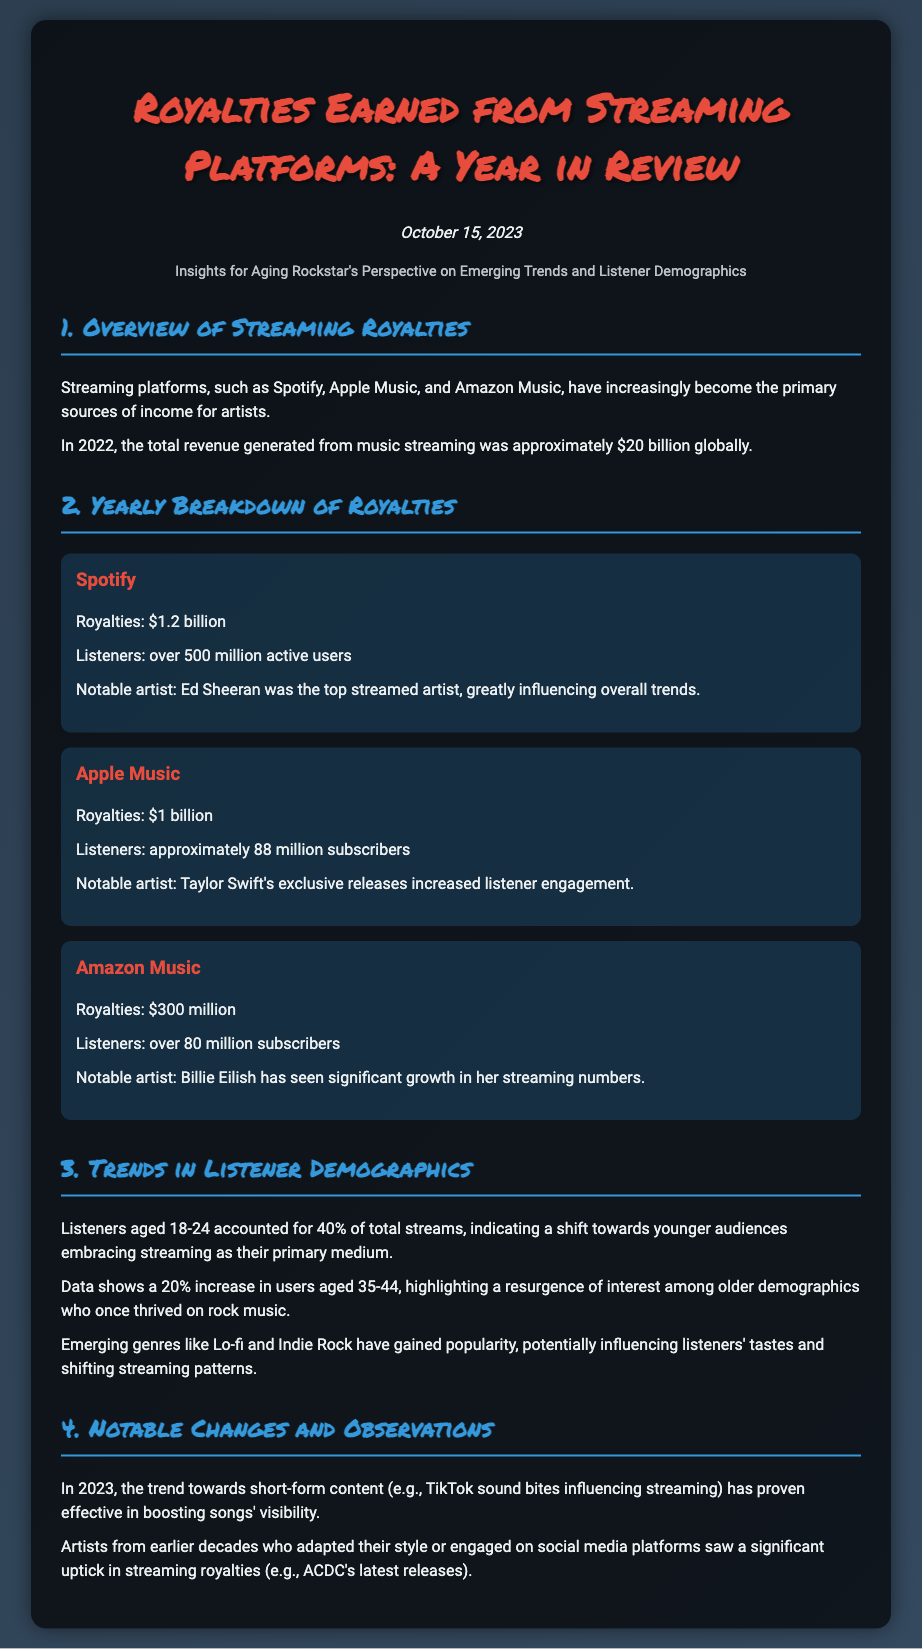What is the total revenue generated from music streaming in 2022? The document states the total revenue generated from music streaming was approximately $20 billion globally.
Answer: $20 billion How much did Spotify earn in royalties? The document specifies that Spotify earned royalties of $1.2 billion.
Answer: $1.2 billion What age group accounted for 40% of total streams? The document mentions that listeners aged 18-24 accounted for 40% of total streams.
Answer: 18-24 Which artist had significant influence on Spotify's streaming trends? According to the document, Ed Sheeran was the top streamed artist on Spotify.
Answer: Ed Sheeran What was the notable observation regarding older demographics? The document highlights a 20% increase in users aged 35-44, indicating renewed interest among older listeners.
Answer: 20% increase What genre has gained popularity alongside Lo-fi? The document lists Indie Rock as an emerging genre gaining popularity.
Answer: Indie Rock What is the notable trend observed in 2023 regarding content? The document mentions the trend towards short-form content influencing streaming visibility.
Answer: Short-form content How many active users does Spotify have? The document states that Spotify has over 500 million active users.
Answer: Over 500 million Who increased listener engagement on Apple Music? The document credits Taylor Swift with increasing listener engagement through exclusive releases.
Answer: Taylor Swift 